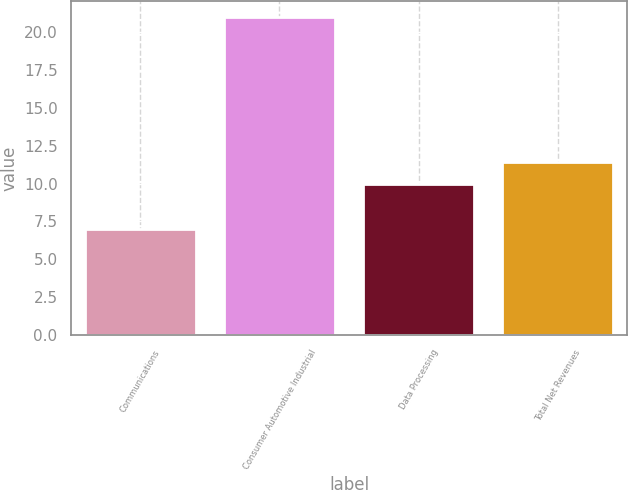Convert chart. <chart><loc_0><loc_0><loc_500><loc_500><bar_chart><fcel>Communications<fcel>Consumer Automotive Industrial<fcel>Data Processing<fcel>Total Net Revenues<nl><fcel>7<fcel>21<fcel>10<fcel>11.4<nl></chart> 